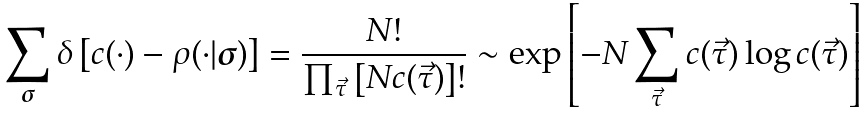Convert formula to latex. <formula><loc_0><loc_0><loc_500><loc_500>\sum _ { \boldsymbol \sigma } \delta \left [ c ( \cdot ) - \rho ( \cdot | \boldsymbol \sigma ) \right ] = \frac { N ! } { \prod _ { \vec { \tau } } \left [ N c ( \vec { \tau } ) \right ] ! } \sim \exp \left [ - N \sum _ { \vec { \tau } } c ( \vec { \tau } ) \log c ( \vec { \tau } ) \right ]</formula> 